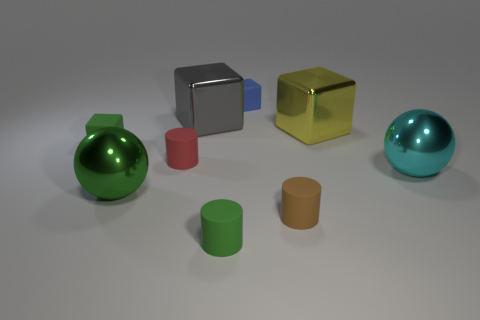Subtract all blue matte cubes. How many cubes are left? 3 Add 1 gray blocks. How many objects exist? 10 Subtract all gray blocks. How many blocks are left? 3 Subtract 1 cylinders. How many cylinders are left? 2 Subtract all blocks. How many objects are left? 5 Add 6 big purple matte balls. How many big purple matte balls exist? 6 Subtract 0 gray spheres. How many objects are left? 9 Subtract all blue cubes. Subtract all cyan cylinders. How many cubes are left? 3 Subtract all yellow metallic blocks. Subtract all blue blocks. How many objects are left? 7 Add 7 big green balls. How many big green balls are left? 8 